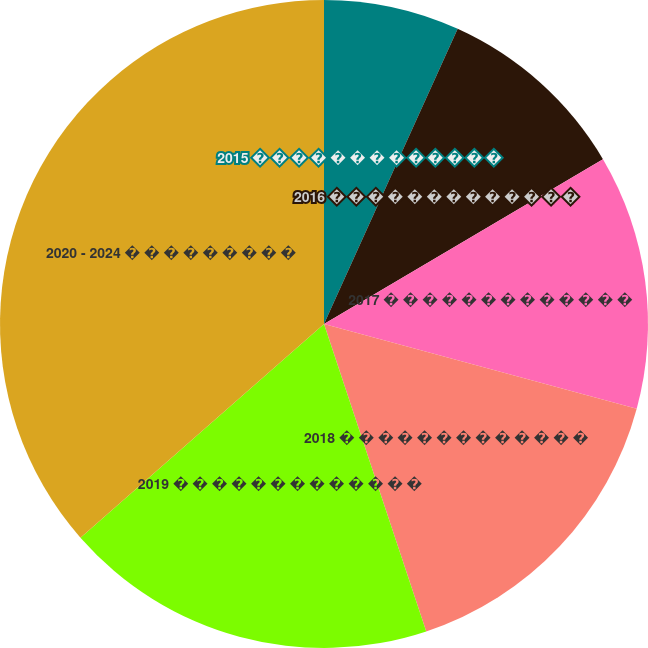Convert chart. <chart><loc_0><loc_0><loc_500><loc_500><pie_chart><fcel>2015 � � � � � � � � � � � � �<fcel>2016 � � � � � � � � � � � � �<fcel>2017 � � � � � � � � � � � � �<fcel>2018 � � � � � � � � � � � � �<fcel>2019 � � � � � � � � � � � � �<fcel>2020 - 2024 � � � � � � � � �<nl><fcel>6.77%<fcel>9.74%<fcel>12.71%<fcel>15.68%<fcel>18.65%<fcel>36.47%<nl></chart> 